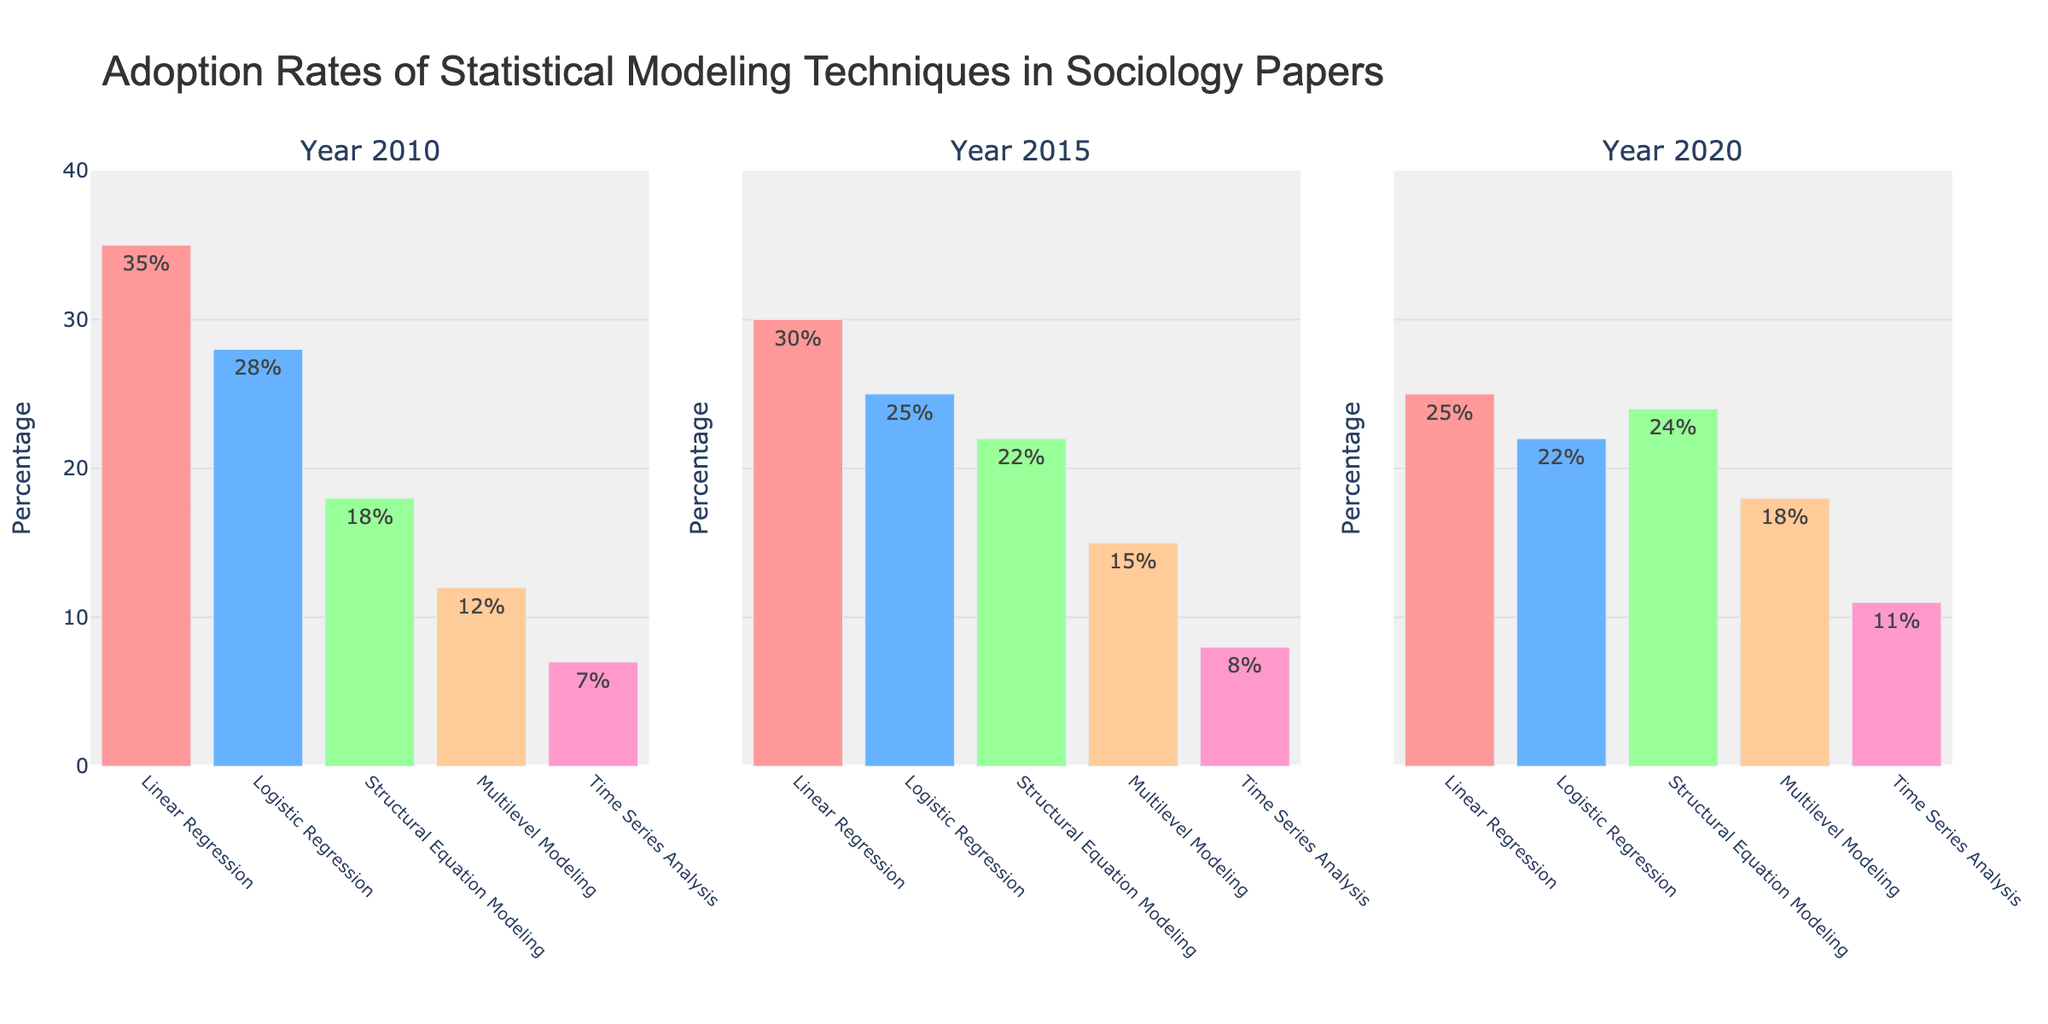What are the three years displayed in the plot? The plot features subplots labeled with the years as titles. By looking at these titles, we can identify the years displayed.
Answer: 2010, 2015, 2020 Which statistical modeling technique had the highest adoption rate in 2010? By examining the bar heights in the subplot for 2010 and considering the hover text for exact percentages, we can see that "Linear Regression" has the tallest bar.
Answer: Linear Regression How did the adoption rate of "Multilevel Modeling" change from 2010 to 2020? To determine the change, we look at the percentage for "Multilevel Modeling" in 2010 and compare it with the percentage in 2020. It increased from 12% to 18%.
Answer: Increased by 6% Which technique saw an increase in adoption rate each year from 2010 to 2020? By analyzing the adoption rates displayed in each subplot year, we find that "Time Series Analysis" increased consistently from 7% in 2010, to 8% in 2015, and to 11% in 2020.
Answer: Time Series Analysis What is the combined adoption rate for "Logistic Regression" in 2010 and 2015? We add the percentages of "Logistic Regression" from 2010 and 2015, which are 28% and 25%, respectively. (28 + 25 = 53)
Answer: 53% Which technique had the least change in adoption rate between 2010 and 2020? We compare the absolute differences in percentages from 2010 and 2020 for each technique. "Linear Regression" changed from 35% to 25%, which is a 10% drop, while "Logistic Regression" changed from 28% to 22%, which is a 6% drop. "Structural Equation Modeling" went from 18% to 24%, a 6% increase; "Multilevel Modeling" went from 12% to 18%, a 6% increase; and "Time Series Analysis," from 7% to 11%, increased by 4%. Hence, the least change is for "Time Series Analysis".
Answer: Time Series Analysis Which statistical modeling technique showed the highest variation in adoption rate across all years? We identify the technique with the largest difference between its highest and lowest percentages across 2010, 2015, and 2020. "Linear Regression" varies from 35% in 2010 to 25% in 2020, a difference of 10%.
Answer: Linear Regression In which year was the adoption of "Structural Equation Modeling" the highest? Comparing the adoption rates for "Structural Equation Modeling" across the three subplots, we observe that the highest rate is 24% in 2020.
Answer: 2020 How many techniques had their adoption rate declining from 2010 to 2020? By examining changes from 2010 to 2020 for each technique, we see that "Linear Regression" decreased from 35% to 25%, and "Logistic Regression" decreased from 28% to 22%. Thus, two techniques experienced a decline.
Answer: Two What is the percentage difference of "Time Series Analysis" adoption between 2010 and 2020? By subtracting the percentage of "Time Series Analysis" in 2010 (7%) from that in 2020 (11%), we find the difference is (11 - 7 = 4).
Answer: 4% 